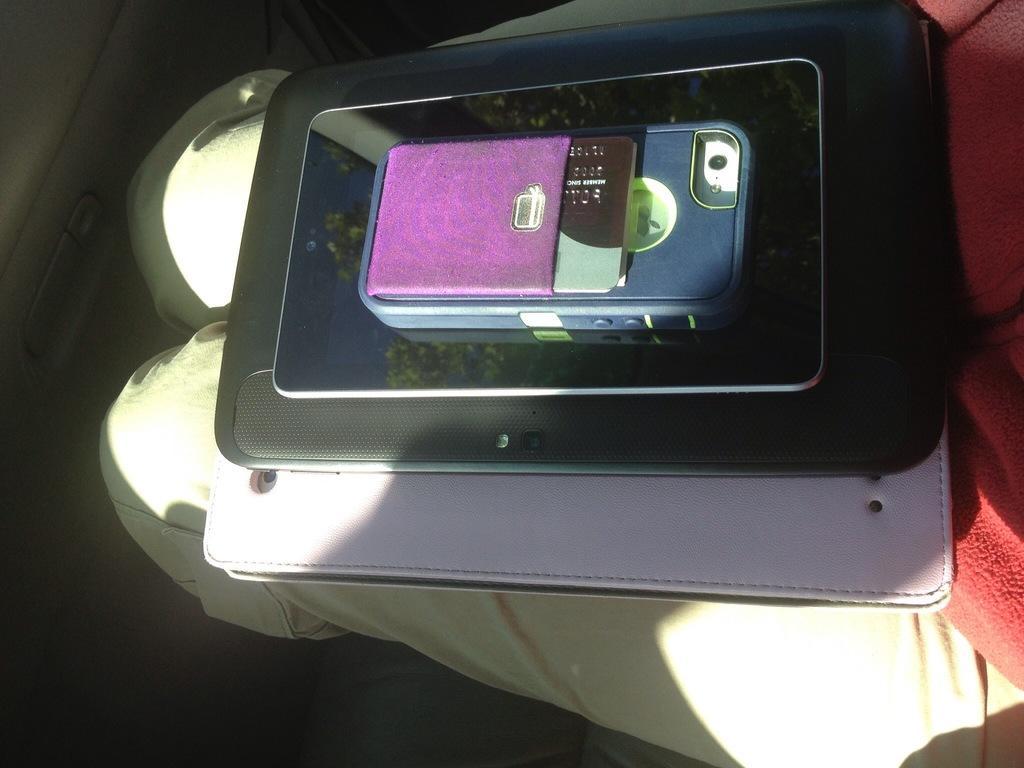Describe this image in one or two sentences. In this image I can see few electronic devices and on the top of it I can see a card. I can also see a red colour cloth and a pant in the background. 